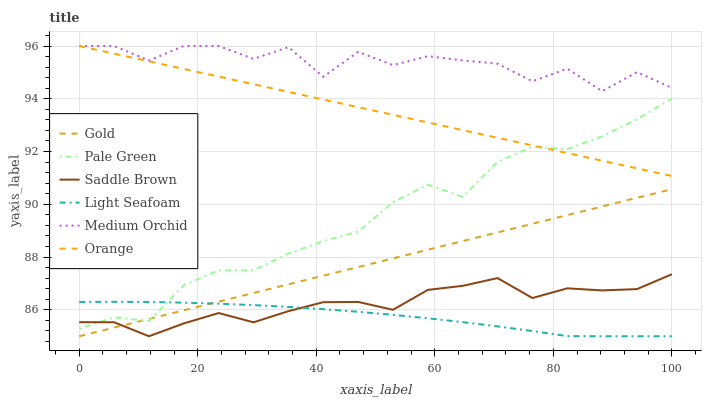Does Light Seafoam have the minimum area under the curve?
Answer yes or no. Yes. Does Medium Orchid have the maximum area under the curve?
Answer yes or no. Yes. Does Pale Green have the minimum area under the curve?
Answer yes or no. No. Does Pale Green have the maximum area under the curve?
Answer yes or no. No. Is Gold the smoothest?
Answer yes or no. Yes. Is Medium Orchid the roughest?
Answer yes or no. Yes. Is Pale Green the smoothest?
Answer yes or no. No. Is Pale Green the roughest?
Answer yes or no. No. Does Pale Green have the lowest value?
Answer yes or no. No. Does Orange have the highest value?
Answer yes or no. Yes. Does Pale Green have the highest value?
Answer yes or no. No. Is Pale Green less than Medium Orchid?
Answer yes or no. Yes. Is Medium Orchid greater than Saddle Brown?
Answer yes or no. Yes. Does Pale Green intersect Medium Orchid?
Answer yes or no. No. 